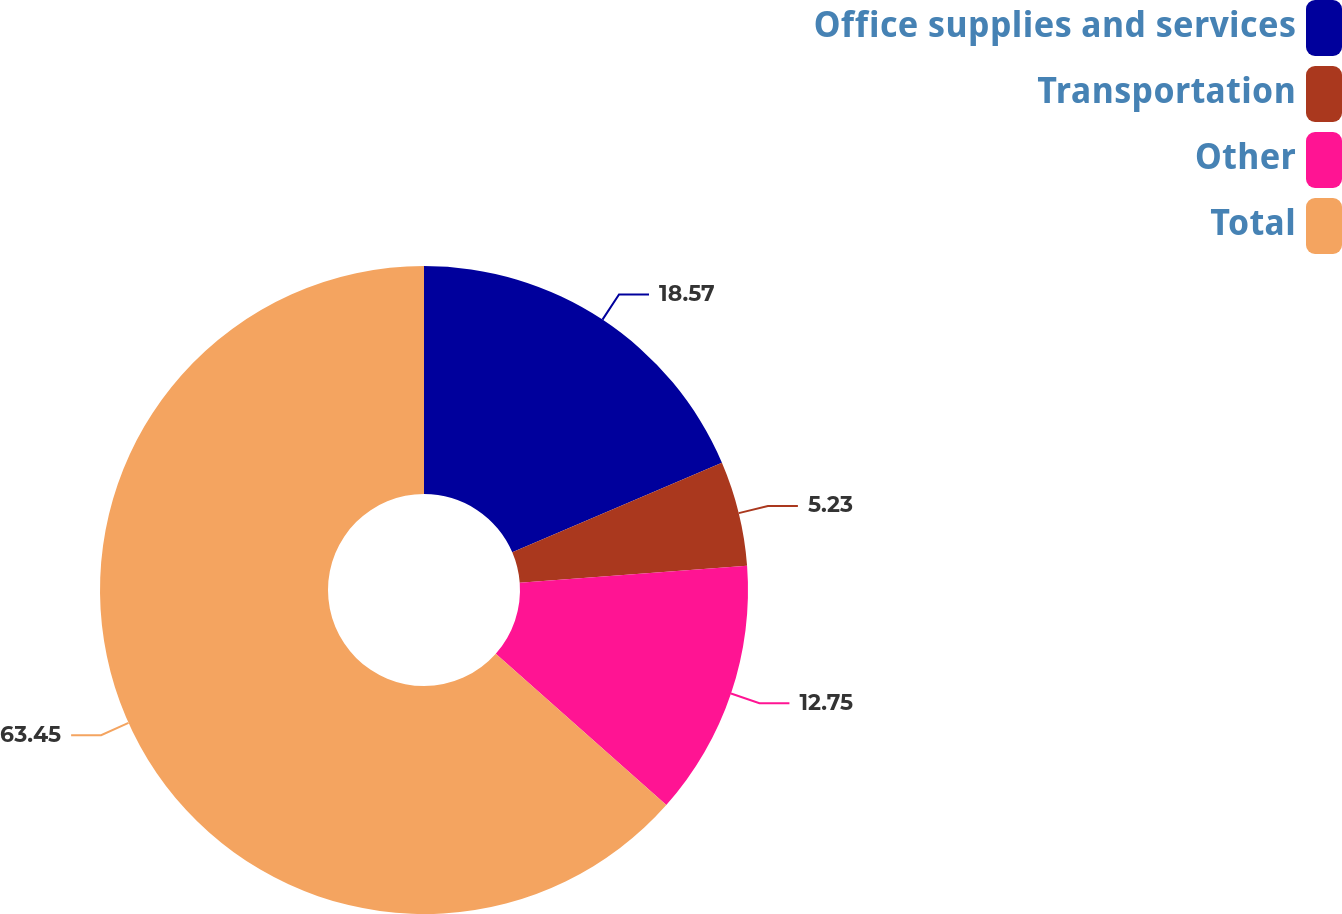Convert chart. <chart><loc_0><loc_0><loc_500><loc_500><pie_chart><fcel>Office supplies and services<fcel>Transportation<fcel>Other<fcel>Total<nl><fcel>18.57%<fcel>5.23%<fcel>12.75%<fcel>63.44%<nl></chart> 